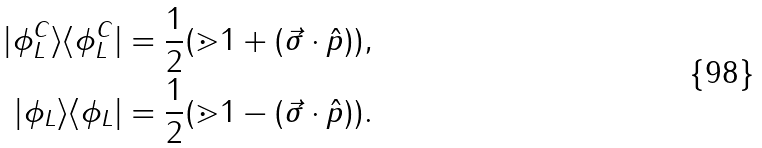<formula> <loc_0><loc_0><loc_500><loc_500>| \phi _ { L } ^ { C } \rangle \langle \phi _ { L } ^ { C } | & = \frac { 1 } { 2 } ( \mathbb { m } { 1 } + ( \vec { \sigma } \cdot \hat { p } ) ) , \\ | \phi _ { L } \rangle \langle \phi _ { L } | & = \frac { 1 } { 2 } ( \mathbb { m } { 1 } - ( \vec { \sigma } \cdot \hat { p } ) ) .</formula> 